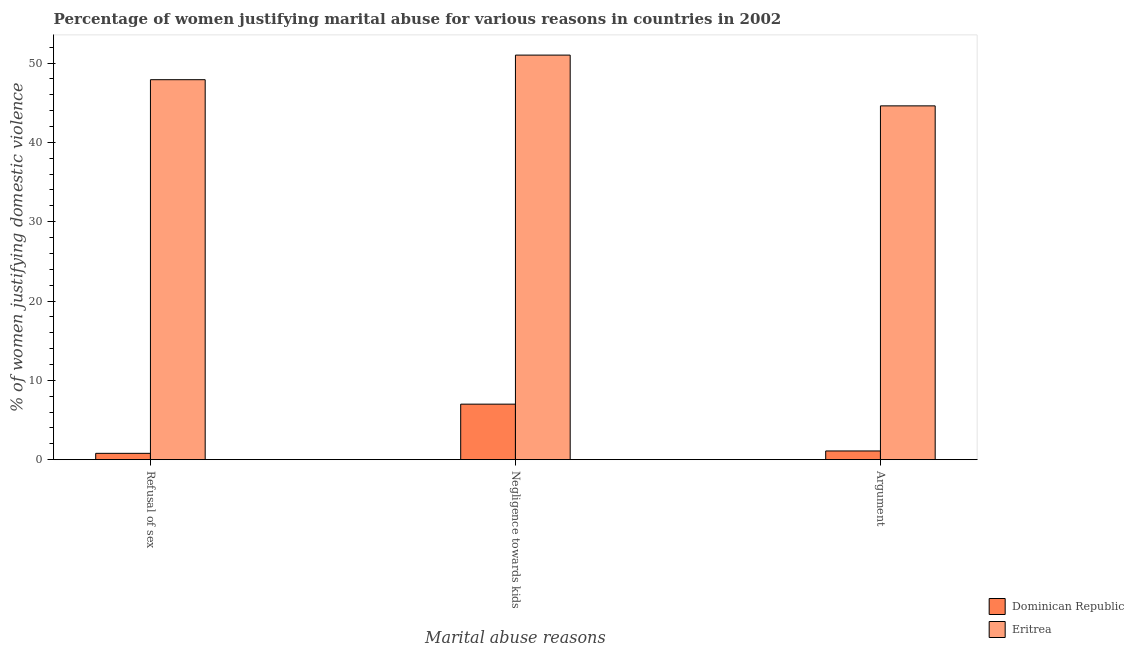How many different coloured bars are there?
Your answer should be compact. 2. How many bars are there on the 1st tick from the left?
Give a very brief answer. 2. What is the label of the 3rd group of bars from the left?
Ensure brevity in your answer.  Argument. Across all countries, what is the maximum percentage of women justifying domestic violence due to refusal of sex?
Make the answer very short. 47.9. In which country was the percentage of women justifying domestic violence due to arguments maximum?
Ensure brevity in your answer.  Eritrea. In which country was the percentage of women justifying domestic violence due to arguments minimum?
Provide a short and direct response. Dominican Republic. What is the difference between the percentage of women justifying domestic violence due to arguments in Eritrea and that in Dominican Republic?
Your answer should be compact. 43.5. What is the difference between the percentage of women justifying domestic violence due to negligence towards kids in Eritrea and the percentage of women justifying domestic violence due to refusal of sex in Dominican Republic?
Your response must be concise. 50.2. What is the average percentage of women justifying domestic violence due to arguments per country?
Keep it short and to the point. 22.85. What is the difference between the percentage of women justifying domestic violence due to negligence towards kids and percentage of women justifying domestic violence due to arguments in Dominican Republic?
Offer a terse response. 5.9. What is the ratio of the percentage of women justifying domestic violence due to negligence towards kids in Eritrea to that in Dominican Republic?
Offer a terse response. 7.29. Is the percentage of women justifying domestic violence due to arguments in Dominican Republic less than that in Eritrea?
Provide a succinct answer. Yes. Is the difference between the percentage of women justifying domestic violence due to arguments in Eritrea and Dominican Republic greater than the difference between the percentage of women justifying domestic violence due to refusal of sex in Eritrea and Dominican Republic?
Your answer should be very brief. No. What is the difference between the highest and the second highest percentage of women justifying domestic violence due to arguments?
Provide a short and direct response. 43.5. What is the difference between the highest and the lowest percentage of women justifying domestic violence due to arguments?
Provide a short and direct response. 43.5. In how many countries, is the percentage of women justifying domestic violence due to refusal of sex greater than the average percentage of women justifying domestic violence due to refusal of sex taken over all countries?
Your answer should be very brief. 1. Is the sum of the percentage of women justifying domestic violence due to refusal of sex in Dominican Republic and Eritrea greater than the maximum percentage of women justifying domestic violence due to negligence towards kids across all countries?
Provide a succinct answer. No. What does the 1st bar from the left in Argument represents?
Your answer should be very brief. Dominican Republic. What does the 2nd bar from the right in Argument represents?
Offer a terse response. Dominican Republic. Is it the case that in every country, the sum of the percentage of women justifying domestic violence due to refusal of sex and percentage of women justifying domestic violence due to negligence towards kids is greater than the percentage of women justifying domestic violence due to arguments?
Offer a very short reply. Yes. Are all the bars in the graph horizontal?
Offer a very short reply. No. What is the difference between two consecutive major ticks on the Y-axis?
Offer a very short reply. 10. Are the values on the major ticks of Y-axis written in scientific E-notation?
Your answer should be very brief. No. Does the graph contain any zero values?
Your response must be concise. No. How many legend labels are there?
Keep it short and to the point. 2. How are the legend labels stacked?
Make the answer very short. Vertical. What is the title of the graph?
Provide a succinct answer. Percentage of women justifying marital abuse for various reasons in countries in 2002. What is the label or title of the X-axis?
Keep it short and to the point. Marital abuse reasons. What is the label or title of the Y-axis?
Offer a terse response. % of women justifying domestic violence. What is the % of women justifying domestic violence of Dominican Republic in Refusal of sex?
Make the answer very short. 0.8. What is the % of women justifying domestic violence in Eritrea in Refusal of sex?
Provide a succinct answer. 47.9. What is the % of women justifying domestic violence of Dominican Republic in Negligence towards kids?
Offer a terse response. 7. What is the % of women justifying domestic violence of Dominican Republic in Argument?
Keep it short and to the point. 1.1. What is the % of women justifying domestic violence of Eritrea in Argument?
Your response must be concise. 44.6. Across all Marital abuse reasons, what is the maximum % of women justifying domestic violence in Dominican Republic?
Your answer should be very brief. 7. Across all Marital abuse reasons, what is the maximum % of women justifying domestic violence of Eritrea?
Your answer should be compact. 51. Across all Marital abuse reasons, what is the minimum % of women justifying domestic violence in Eritrea?
Ensure brevity in your answer.  44.6. What is the total % of women justifying domestic violence in Eritrea in the graph?
Offer a terse response. 143.5. What is the difference between the % of women justifying domestic violence of Dominican Republic in Refusal of sex and that in Negligence towards kids?
Give a very brief answer. -6.2. What is the difference between the % of women justifying domestic violence in Eritrea in Refusal of sex and that in Negligence towards kids?
Your answer should be very brief. -3.1. What is the difference between the % of women justifying domestic violence in Dominican Republic in Negligence towards kids and that in Argument?
Offer a terse response. 5.9. What is the difference between the % of women justifying domestic violence in Dominican Republic in Refusal of sex and the % of women justifying domestic violence in Eritrea in Negligence towards kids?
Provide a short and direct response. -50.2. What is the difference between the % of women justifying domestic violence of Dominican Republic in Refusal of sex and the % of women justifying domestic violence of Eritrea in Argument?
Ensure brevity in your answer.  -43.8. What is the difference between the % of women justifying domestic violence of Dominican Republic in Negligence towards kids and the % of women justifying domestic violence of Eritrea in Argument?
Your answer should be very brief. -37.6. What is the average % of women justifying domestic violence in Dominican Republic per Marital abuse reasons?
Make the answer very short. 2.97. What is the average % of women justifying domestic violence in Eritrea per Marital abuse reasons?
Provide a succinct answer. 47.83. What is the difference between the % of women justifying domestic violence of Dominican Republic and % of women justifying domestic violence of Eritrea in Refusal of sex?
Provide a short and direct response. -47.1. What is the difference between the % of women justifying domestic violence of Dominican Republic and % of women justifying domestic violence of Eritrea in Negligence towards kids?
Provide a succinct answer. -44. What is the difference between the % of women justifying domestic violence of Dominican Republic and % of women justifying domestic violence of Eritrea in Argument?
Make the answer very short. -43.5. What is the ratio of the % of women justifying domestic violence in Dominican Republic in Refusal of sex to that in Negligence towards kids?
Your answer should be very brief. 0.11. What is the ratio of the % of women justifying domestic violence of Eritrea in Refusal of sex to that in Negligence towards kids?
Offer a terse response. 0.94. What is the ratio of the % of women justifying domestic violence of Dominican Republic in Refusal of sex to that in Argument?
Your response must be concise. 0.73. What is the ratio of the % of women justifying domestic violence in Eritrea in Refusal of sex to that in Argument?
Your answer should be very brief. 1.07. What is the ratio of the % of women justifying domestic violence of Dominican Republic in Negligence towards kids to that in Argument?
Make the answer very short. 6.36. What is the ratio of the % of women justifying domestic violence in Eritrea in Negligence towards kids to that in Argument?
Your answer should be compact. 1.14. What is the difference between the highest and the second highest % of women justifying domestic violence of Dominican Republic?
Ensure brevity in your answer.  5.9. What is the difference between the highest and the second highest % of women justifying domestic violence in Eritrea?
Your response must be concise. 3.1. What is the difference between the highest and the lowest % of women justifying domestic violence in Dominican Republic?
Keep it short and to the point. 6.2. 